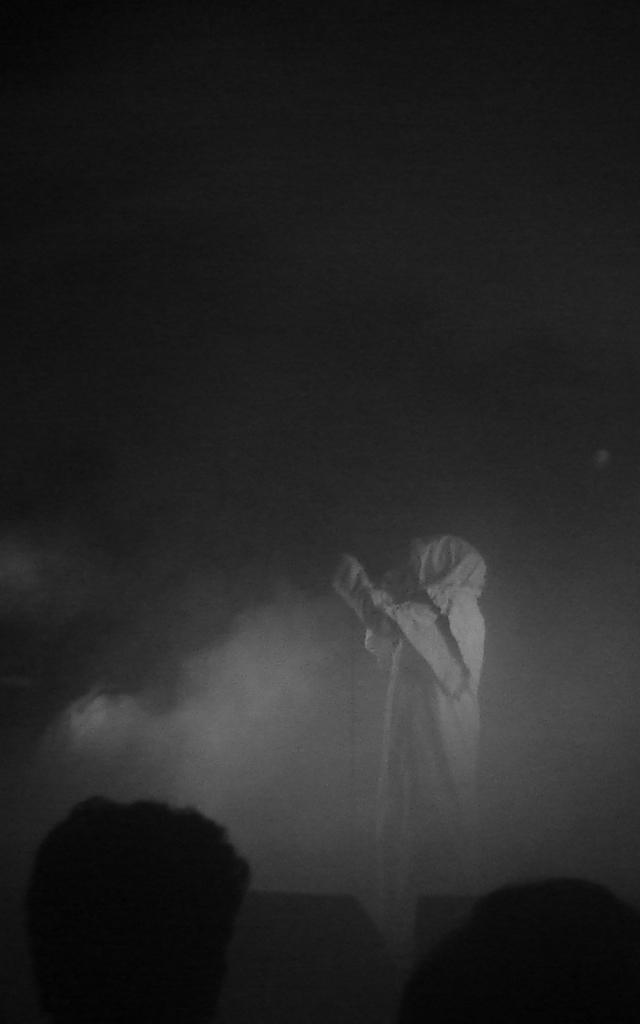What can be observed about the image's appearance? The image appears to be edited. What is the main subject in the center of the image? There is an object in the center of the image that resembles a person. What is the presence of in the image? There is smoke visible in the image. What does the caption say about the sun on the side of the image? There is no caption present in the image, and the sun is not mentioned or visible. 